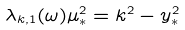<formula> <loc_0><loc_0><loc_500><loc_500>\lambda _ { k , 1 } ( \omega ) \mu _ { * } ^ { 2 } = k ^ { 2 } - y _ { * } ^ { 2 }</formula> 